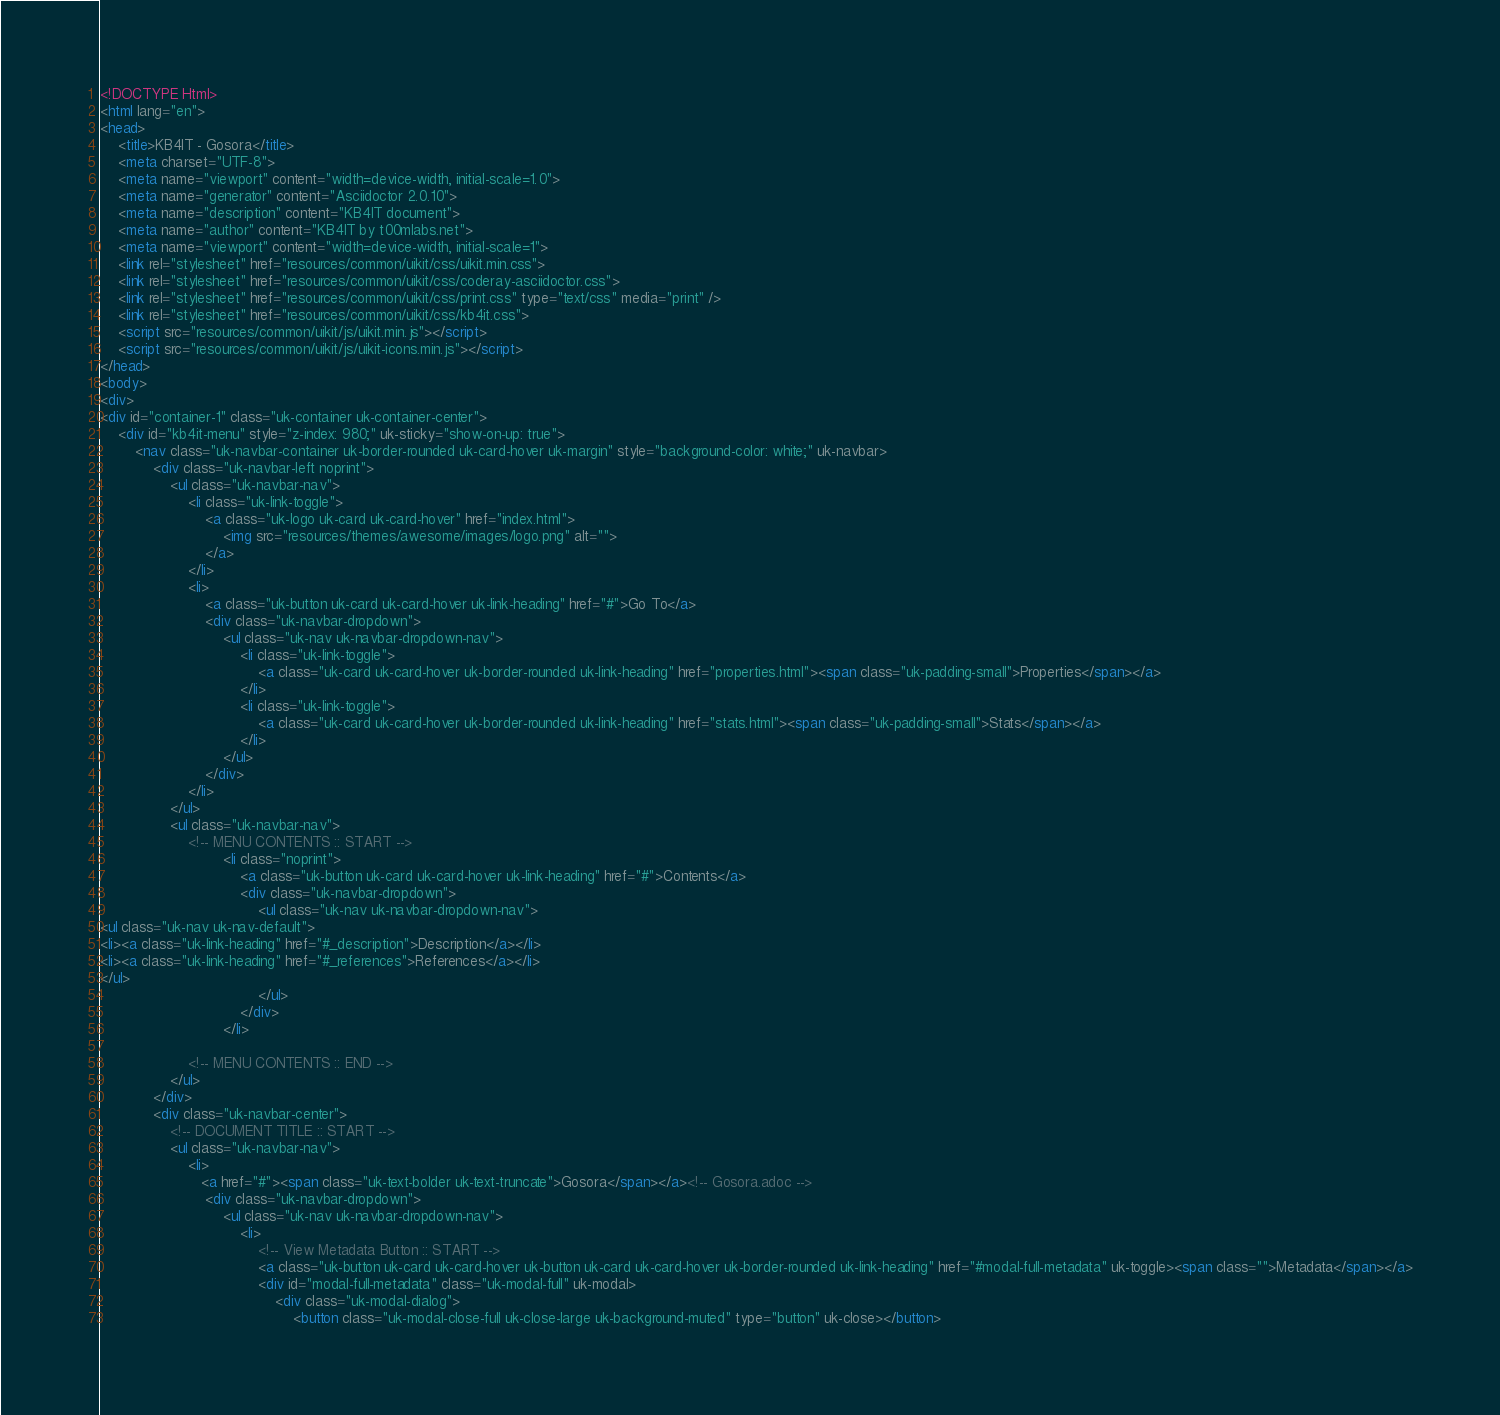<code> <loc_0><loc_0><loc_500><loc_500><_HTML_><!DOCTYPE Html>
<html lang="en">
<head>
    <title>KB4IT - Gosora</title>
    <meta charset="UTF-8">
    <meta name="viewport" content="width=device-width, initial-scale=1.0">
    <meta name="generator" content="Asciidoctor 2.0.10">
    <meta name="description" content="KB4IT document">
    <meta name="author" content="KB4IT by t00mlabs.net">
    <meta name="viewport" content="width=device-width, initial-scale=1">
    <link rel="stylesheet" href="resources/common/uikit/css/uikit.min.css">
    <link rel="stylesheet" href="resources/common/uikit/css/coderay-asciidoctor.css">
    <link rel="stylesheet" href="resources/common/uikit/css/print.css" type="text/css" media="print" />
    <link rel="stylesheet" href="resources/common/uikit/css/kb4it.css">
    <script src="resources/common/uikit/js/uikit.min.js"></script>
    <script src="resources/common/uikit/js/uikit-icons.min.js"></script>
</head>
<body>
<div>
<div id="container-1" class="uk-container uk-container-center">
    <div id="kb4it-menu" style="z-index: 980;" uk-sticky="show-on-up: true">
        <nav class="uk-navbar-container uk-border-rounded uk-card-hover uk-margin" style="background-color: white;" uk-navbar>
            <div class="uk-navbar-left noprint">
                <ul class="uk-navbar-nav">
                    <li class="uk-link-toggle">
                        <a class="uk-logo uk-card uk-card-hover" href="index.html">
                            <img src="resources/themes/awesome/images/logo.png" alt="">
                        </a>
                    </li>
                    <li>
                        <a class="uk-button uk-card uk-card-hover uk-link-heading" href="#">Go To</a>
                        <div class="uk-navbar-dropdown">
                            <ul class="uk-nav uk-navbar-dropdown-nav">
                                <li class="uk-link-toggle">
                                    <a class="uk-card uk-card-hover uk-border-rounded uk-link-heading" href="properties.html"><span class="uk-padding-small">Properties</span></a>
                                </li>
                                <li class="uk-link-toggle">
                                    <a class="uk-card uk-card-hover uk-border-rounded uk-link-heading" href="stats.html"><span class="uk-padding-small">Stats</span></a>
                                </li>
                            </ul>
                        </div>
                    </li>
                </ul>
                <ul class="uk-navbar-nav">
                    <!-- MENU CONTENTS :: START -->
                            <li class="noprint">
                                <a class="uk-button uk-card uk-card-hover uk-link-heading" href="#">Contents</a>
                                <div class="uk-navbar-dropdown">
                                    <ul class="uk-nav uk-navbar-dropdown-nav">
<ul class="uk-nav uk-nav-default">
<li><a class="uk-link-heading" href="#_description">Description</a></li>
<li><a class="uk-link-heading" href="#_references">References</a></li>
</ul>
                                    </ul>
                                </div>
                            </li>

                    <!-- MENU CONTENTS :: END -->
                </ul>
            </div>
            <div class="uk-navbar-center">
                <!-- DOCUMENT TITLE :: START -->
                <ul class="uk-navbar-nav">
                    <li>
                       <a href="#"><span class="uk-text-bolder uk-text-truncate">Gosora</span></a><!-- Gosora.adoc -->
                        <div class="uk-navbar-dropdown">
                            <ul class="uk-nav uk-navbar-dropdown-nav">
                                <li>
                                    <!-- View Metadata Button :: START -->
                                    <a class="uk-button uk-card uk-card-hover uk-button uk-card uk-card-hover uk-border-rounded uk-link-heading" href="#modal-full-metadata" uk-toggle><span class="">Metadata</span></a>
                                    <div id="modal-full-metadata" class="uk-modal-full" uk-modal>
                                        <div class="uk-modal-dialog">
                                            <button class="uk-modal-close-full uk-close-large uk-background-muted" type="button" uk-close></button></code> 